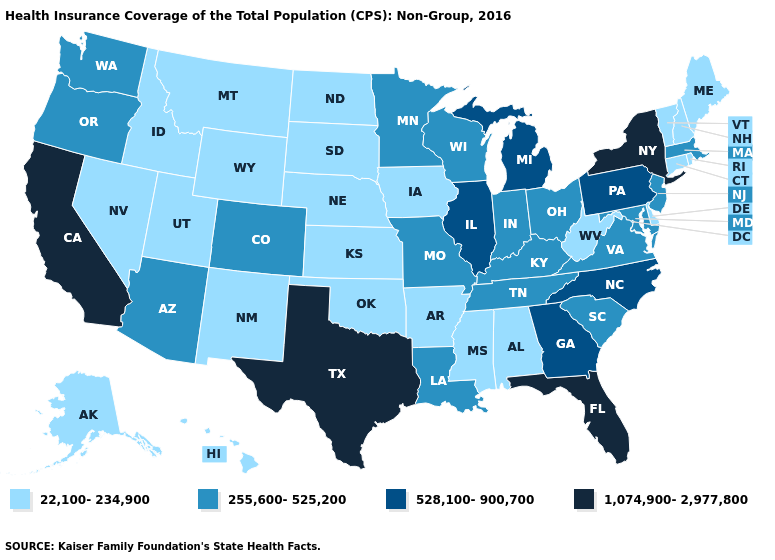What is the value of California?
Be succinct. 1,074,900-2,977,800. Which states have the highest value in the USA?
Keep it brief. California, Florida, New York, Texas. Does Idaho have the highest value in the USA?
Write a very short answer. No. Name the states that have a value in the range 22,100-234,900?
Concise answer only. Alabama, Alaska, Arkansas, Connecticut, Delaware, Hawaii, Idaho, Iowa, Kansas, Maine, Mississippi, Montana, Nebraska, Nevada, New Hampshire, New Mexico, North Dakota, Oklahoma, Rhode Island, South Dakota, Utah, Vermont, West Virginia, Wyoming. Name the states that have a value in the range 22,100-234,900?
Concise answer only. Alabama, Alaska, Arkansas, Connecticut, Delaware, Hawaii, Idaho, Iowa, Kansas, Maine, Mississippi, Montana, Nebraska, Nevada, New Hampshire, New Mexico, North Dakota, Oklahoma, Rhode Island, South Dakota, Utah, Vermont, West Virginia, Wyoming. What is the value of Arkansas?
Short answer required. 22,100-234,900. Does Wisconsin have the lowest value in the USA?
Quick response, please. No. What is the value of Rhode Island?
Quick response, please. 22,100-234,900. What is the highest value in states that border Nebraska?
Give a very brief answer. 255,600-525,200. Does the map have missing data?
Concise answer only. No. Is the legend a continuous bar?
Quick response, please. No. What is the lowest value in the MidWest?
Write a very short answer. 22,100-234,900. Which states have the highest value in the USA?
Concise answer only. California, Florida, New York, Texas. Among the states that border Kentucky , does Tennessee have the lowest value?
Give a very brief answer. No. What is the highest value in the West ?
Concise answer only. 1,074,900-2,977,800. 